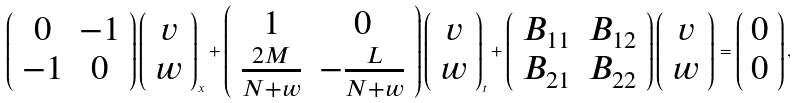Convert formula to latex. <formula><loc_0><loc_0><loc_500><loc_500>\left ( \begin{array} { c c } 0 & - 1 \\ - 1 & 0 \\ \end{array} \right ) \left ( \begin{array} { c } v \\ w \\ \end{array} \right ) _ { x } + \left ( \begin{array} { c c } 1 & 0 \\ \frac { 2 M } { N + w } & - \frac { L } { N + w } \\ \end{array} \right ) \left ( \begin{array} { c } v \\ w \\ \end{array} \right ) _ { t } + \left ( \begin{array} { c c } B _ { 1 1 } & B _ { 1 2 } \\ B _ { 2 1 } & B _ { 2 2 } \\ \end{array} \right ) \left ( \begin{array} { c } v \\ w \\ \end{array} \right ) = \left ( \begin{array} { c } 0 \\ 0 \\ \end{array} \right ) ,</formula> 